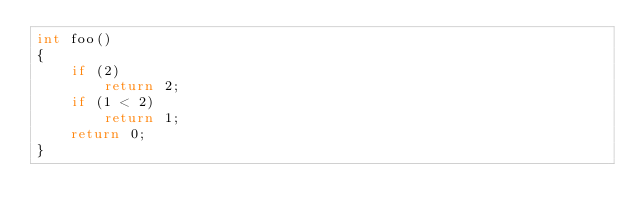<code> <loc_0><loc_0><loc_500><loc_500><_C++_>int foo()
{
    if (2)
        return 2;
    if (1 < 2)
        return 1;
    return 0;
}
</code> 